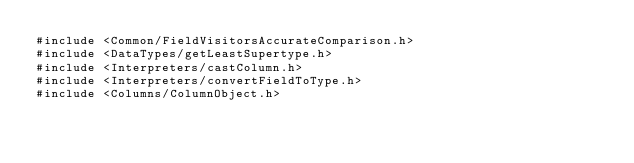Convert code to text. <code><loc_0><loc_0><loc_500><loc_500><_C++_>#include <Common/FieldVisitorsAccurateComparison.h>
#include <DataTypes/getLeastSupertype.h>
#include <Interpreters/castColumn.h>
#include <Interpreters/convertFieldToType.h>
#include <Columns/ColumnObject.h></code> 